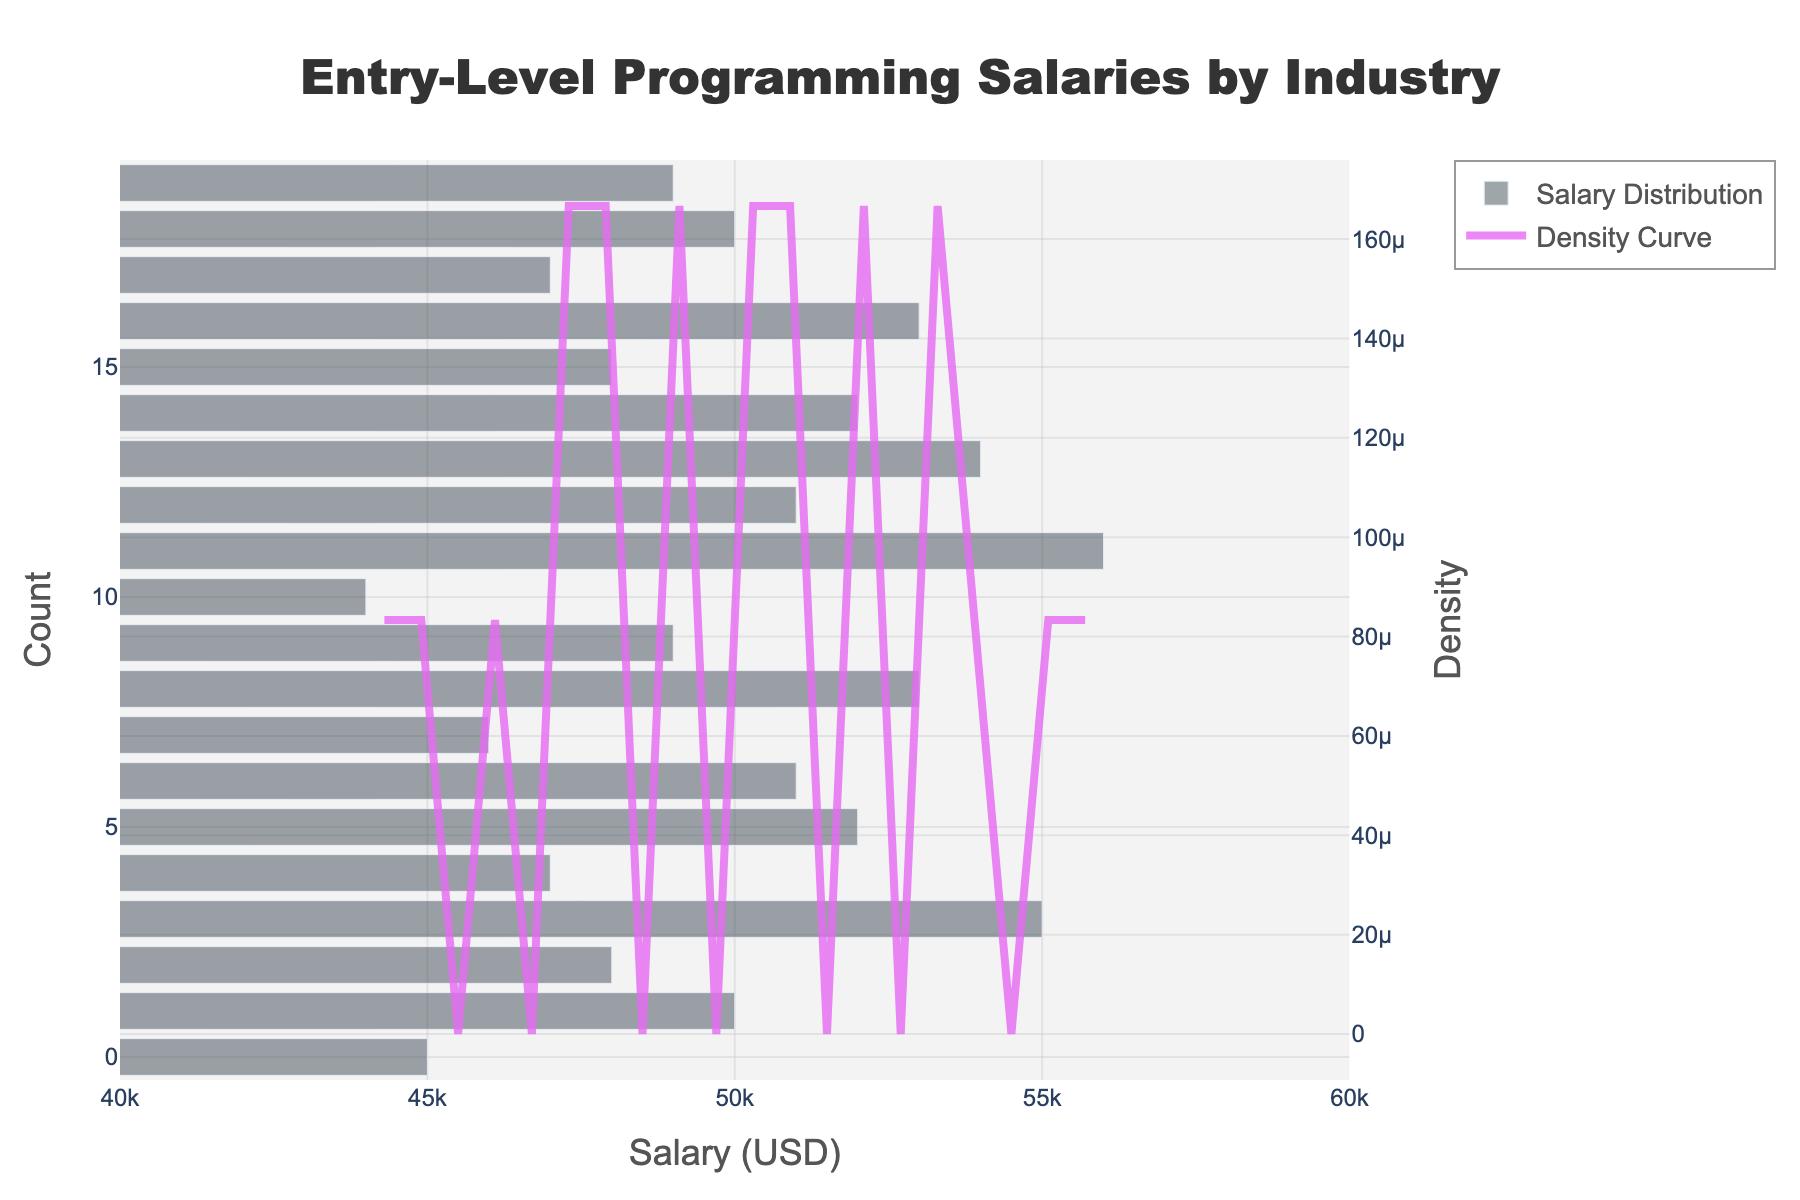What is the title of the figure? The figure's title is displayed prominently at the top and indicates the subject matter of the plot.
Answer: Entry-Level Programming Salaries by Industry What is the x-axis title? The x-axis title is located below the x-axis and it specifies what the x-axis represents.
Answer: Salary (USD) What is the range of salaries shown on the x-axis? The x-axis range is indicated by the values at the leftmost and rightmost points of the x-axis.
Answer: 40000 to 60000 USD Which industry offers the highest entry-level salary according to the chart? To find the highest salary, observe the rightmost bar in the histogram, which represents the highest salary value.
Answer: AI/Machine Learning Which industry offers the lowest entry-level salary according to the chart? To find the lowest salary, observe the leftmost bar in the histogram, which represents the lowest salary value.
Answer: EdTech What is shown by the red line in the plot? The red line on the plot represents the KDE (kernel density estimate) curve which shows the distribution of the salary data.
Answer: Density Curve How many industries have entry-level salaries above 50,000 USD? Count the bars or data points on the histogram that fall above the 50,000 salary mark on the x-axis.
Answer: 9 industries What is the most common salary range for entry-level programming positions according to the histogram? The most common salary range corresponds to the height of the tallest bar on the histogram. Identify the range of salaries that this bar covers.
Answer: 50,000 to 55,000 USD Is the distribution of entry-level salaries skewed towards higher or lower values? Observe the shape of the histogram and the KDE curve; skewness is determined by the tail direction. If it has a longer tail on one side, it's skewed towards that side.
Answer: Skewed towards higher values If an entry-level position offers a salary of 52,000 USD, is it above or below the average entry-level salary according to the data shown? Locate the position of 52,000 on the x-axis, then estimate if it's to the right or left of the histogram’s and KDE curve’s center. This gives an idea if it's above or below the average.
Answer: Above the average 